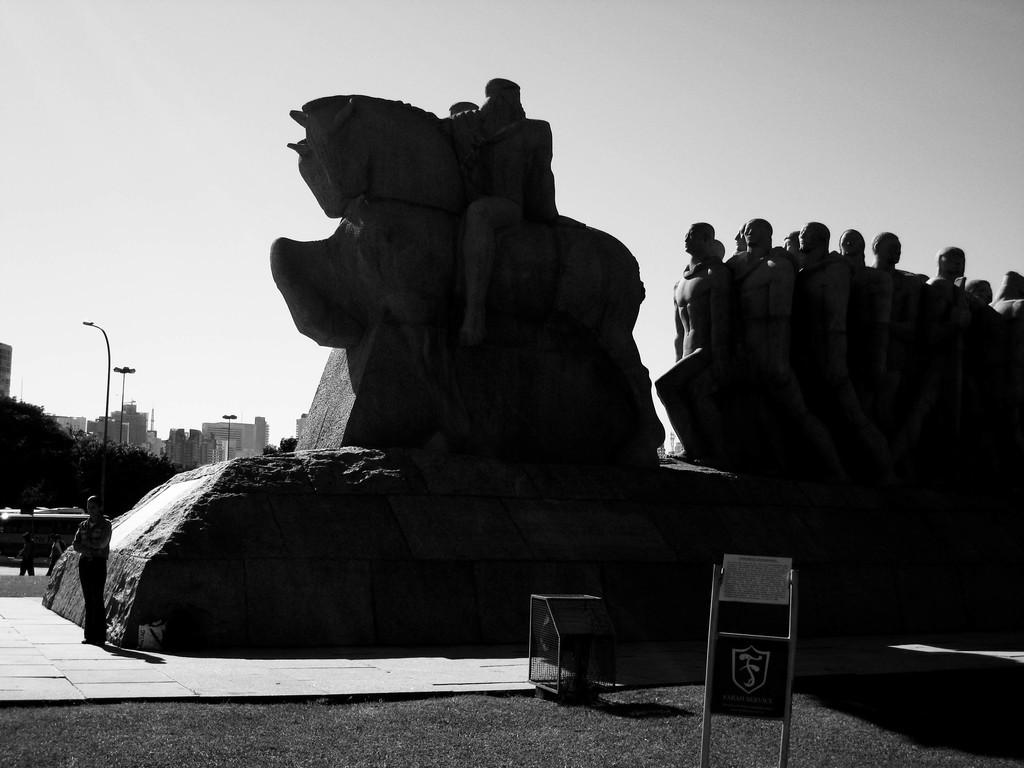What is the main subject in the image? There is a sculpture in the image. Can you describe the person in the image? There is a person standing in the image. What type of natural elements can be seen in the image? There are trees in the image. What type of man-made structures are visible in the image? There are buildings in the image. What is visible in the sky in the image? The sky is visible in the image. What type of signage is present in the image? There is a sign board in the image. What type of iron object is on the ground in the image? There is an iron object on the ground in the image. What type of leaf is falling from the trees in the image? There are no leaves falling from the trees in the image; it only shows trees. What type of quartz is embedded in the sculpture in the image? There is no mention of quartz in the image, and it is not visible in the sculpture. 